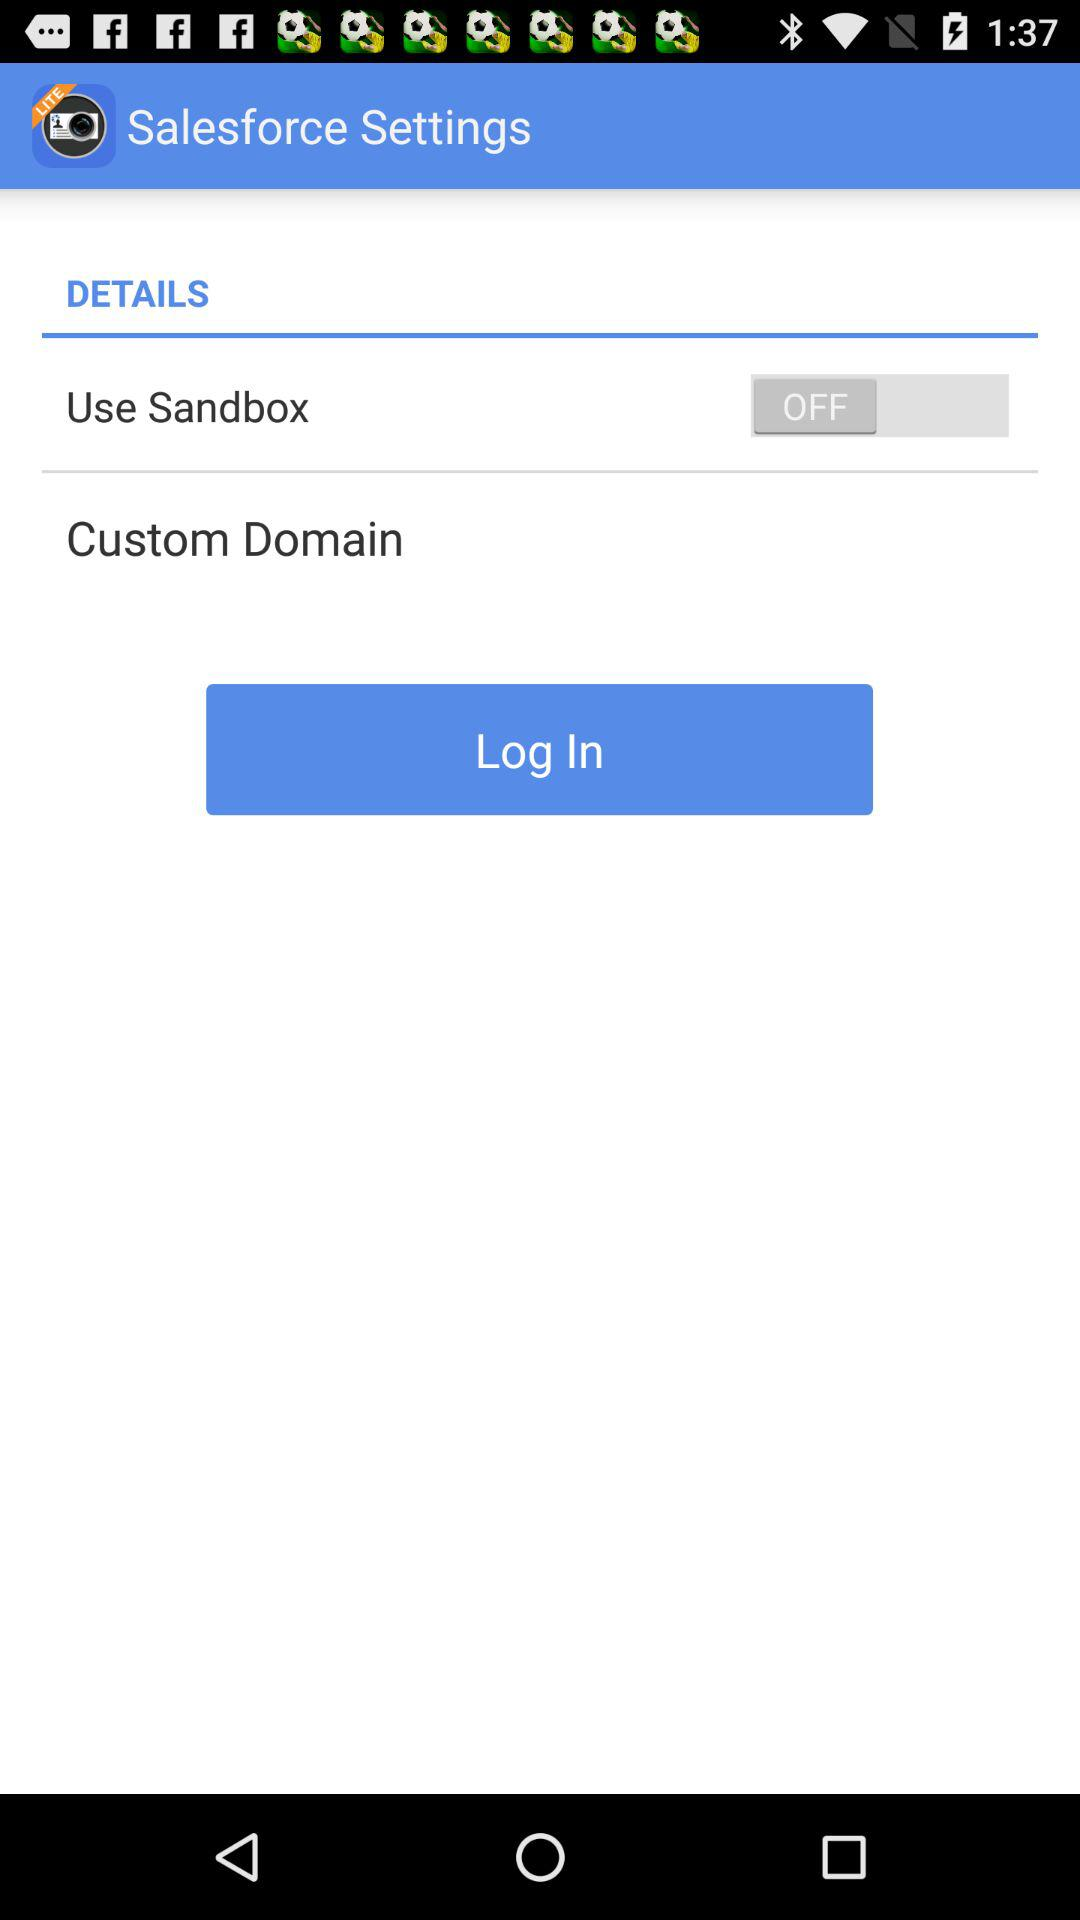What is the setting for "Use Sandbox"? The setting for "Use Sandbox" is "off". 